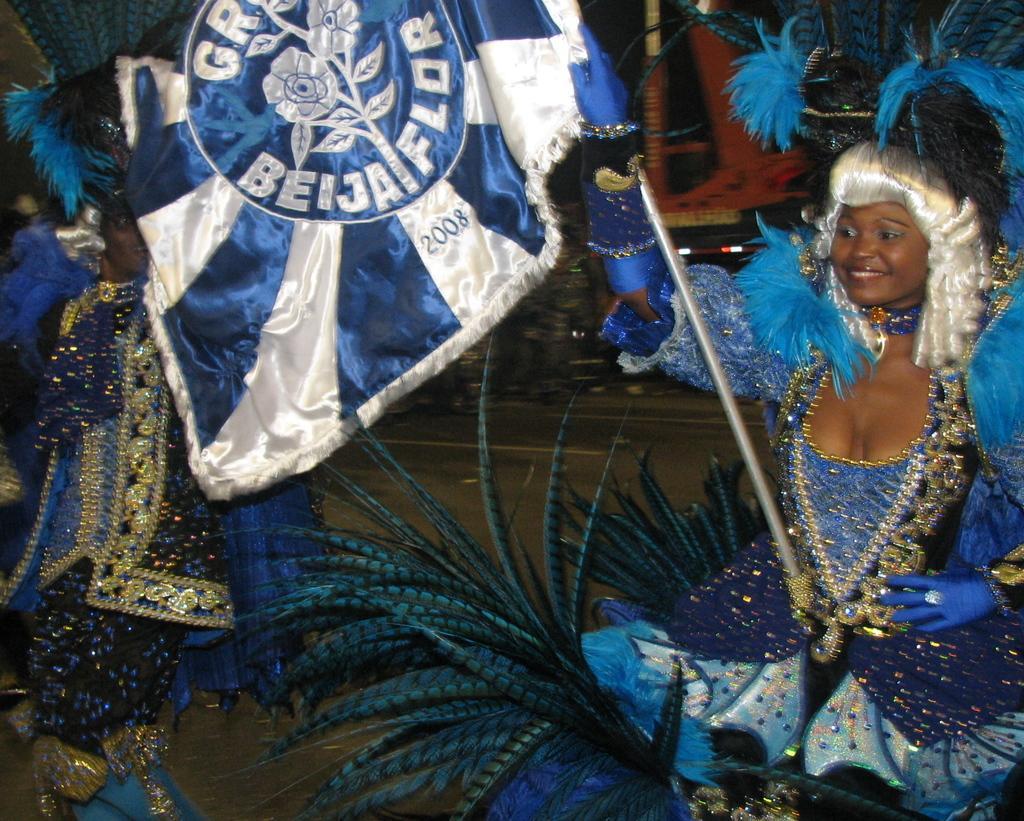Can you describe this image briefly? There is a lady on the right side of the image, by holding a flag in her hand, she is wearing a costume and there is another lady on the left side. 